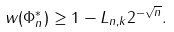Convert formula to latex. <formula><loc_0><loc_0><loc_500><loc_500>w ( \Phi _ { n } ^ { * } ) \geq 1 - L _ { n , k } 2 ^ { - \sqrt { n } } .</formula> 